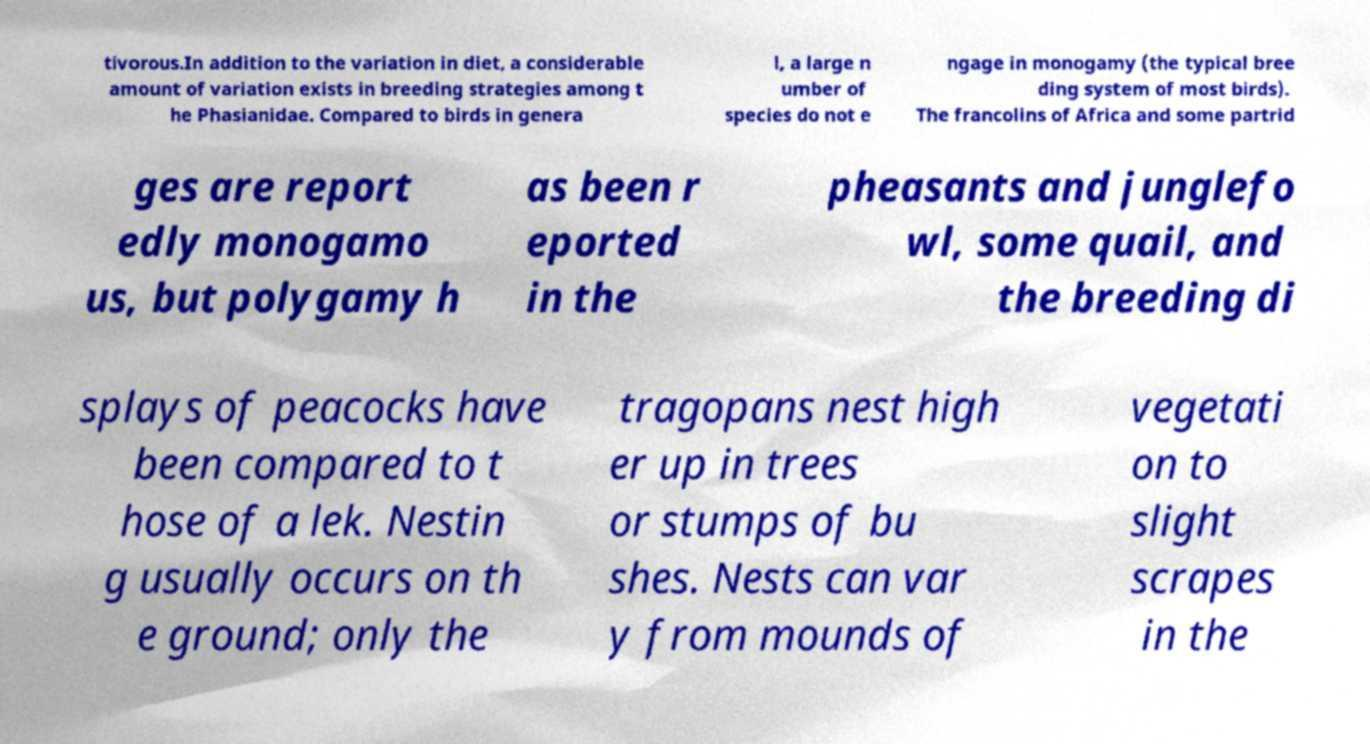Please identify and transcribe the text found in this image. tivorous.In addition to the variation in diet, a considerable amount of variation exists in breeding strategies among t he Phasianidae. Compared to birds in genera l, a large n umber of species do not e ngage in monogamy (the typical bree ding system of most birds). The francolins of Africa and some partrid ges are report edly monogamo us, but polygamy h as been r eported in the pheasants and junglefo wl, some quail, and the breeding di splays of peacocks have been compared to t hose of a lek. Nestin g usually occurs on th e ground; only the tragopans nest high er up in trees or stumps of bu shes. Nests can var y from mounds of vegetati on to slight scrapes in the 